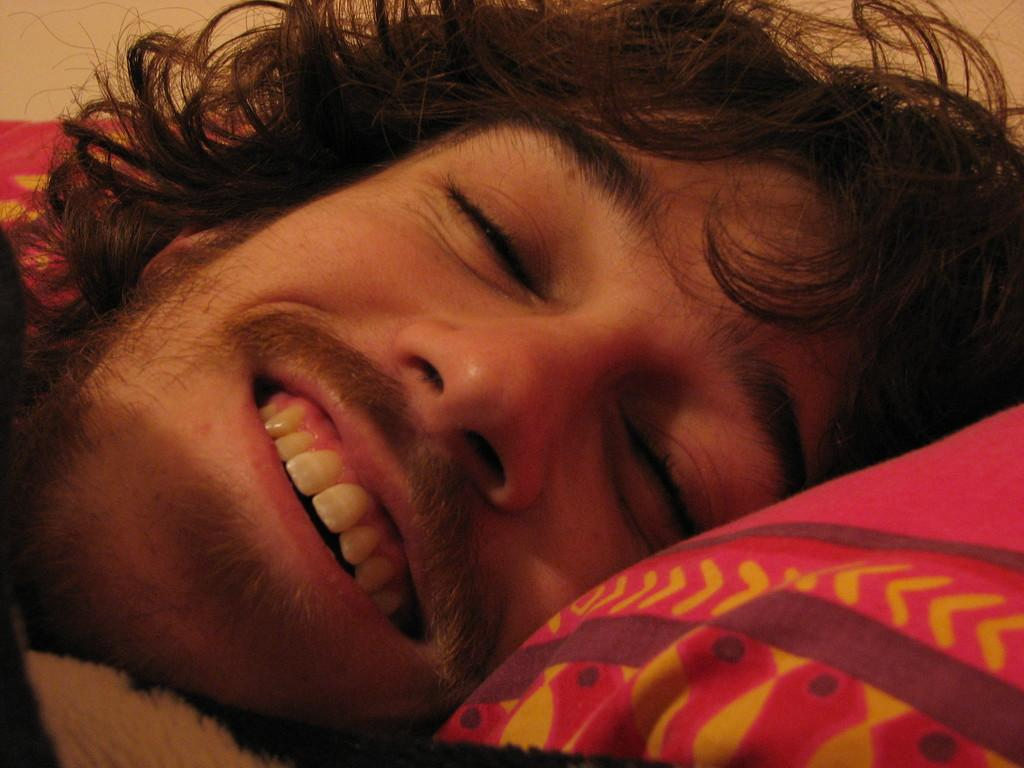Who is present in the image? There is a person in the image. What is the person doing in the image? The person is sleeping. On what object is the person sleeping? The person is sleeping on an object. How does the earthquake affect the person's sleep in the image? There is no earthquake present in the image, so its effect on the person's sleep cannot be determined. 